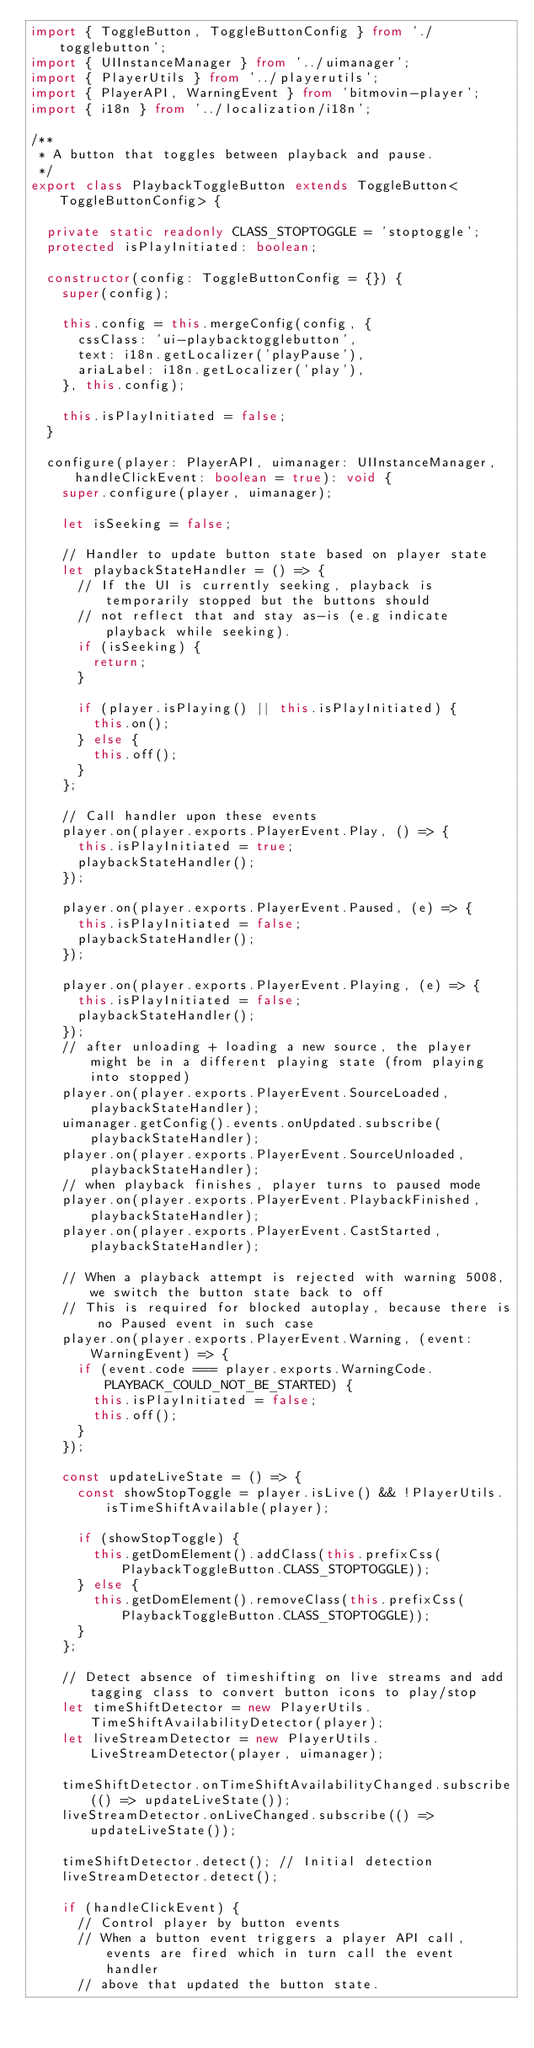<code> <loc_0><loc_0><loc_500><loc_500><_TypeScript_>import { ToggleButton, ToggleButtonConfig } from './togglebutton';
import { UIInstanceManager } from '../uimanager';
import { PlayerUtils } from '../playerutils';
import { PlayerAPI, WarningEvent } from 'bitmovin-player';
import { i18n } from '../localization/i18n';

/**
 * A button that toggles between playback and pause.
 */
export class PlaybackToggleButton extends ToggleButton<ToggleButtonConfig> {

  private static readonly CLASS_STOPTOGGLE = 'stoptoggle';
  protected isPlayInitiated: boolean;

  constructor(config: ToggleButtonConfig = {}) {
    super(config);

    this.config = this.mergeConfig(config, {
      cssClass: 'ui-playbacktogglebutton',
      text: i18n.getLocalizer('playPause'),
      ariaLabel: i18n.getLocalizer('play'),
    }, this.config);

    this.isPlayInitiated = false;
  }

  configure(player: PlayerAPI, uimanager: UIInstanceManager, handleClickEvent: boolean = true): void {
    super.configure(player, uimanager);

    let isSeeking = false;

    // Handler to update button state based on player state
    let playbackStateHandler = () => {
      // If the UI is currently seeking, playback is temporarily stopped but the buttons should
      // not reflect that and stay as-is (e.g indicate playback while seeking).
      if (isSeeking) {
        return;
      }

      if (player.isPlaying() || this.isPlayInitiated) {
        this.on();
      } else {
        this.off();
      }
    };

    // Call handler upon these events
    player.on(player.exports.PlayerEvent.Play, () => {
      this.isPlayInitiated = true;
      playbackStateHandler();
    });

    player.on(player.exports.PlayerEvent.Paused, (e) => {
      this.isPlayInitiated = false;
      playbackStateHandler();
    });

    player.on(player.exports.PlayerEvent.Playing, (e) => {
      this.isPlayInitiated = false;
      playbackStateHandler();
    });
    // after unloading + loading a new source, the player might be in a different playing state (from playing into stopped)
    player.on(player.exports.PlayerEvent.SourceLoaded, playbackStateHandler);
    uimanager.getConfig().events.onUpdated.subscribe(playbackStateHandler);
    player.on(player.exports.PlayerEvent.SourceUnloaded, playbackStateHandler);
    // when playback finishes, player turns to paused mode
    player.on(player.exports.PlayerEvent.PlaybackFinished, playbackStateHandler);
    player.on(player.exports.PlayerEvent.CastStarted, playbackStateHandler);

    // When a playback attempt is rejected with warning 5008, we switch the button state back to off
    // This is required for blocked autoplay, because there is no Paused event in such case
    player.on(player.exports.PlayerEvent.Warning, (event: WarningEvent) => {
      if (event.code === player.exports.WarningCode.PLAYBACK_COULD_NOT_BE_STARTED) {
        this.isPlayInitiated = false;
        this.off();
      }
    });

    const updateLiveState = () => {
      const showStopToggle = player.isLive() && !PlayerUtils.isTimeShiftAvailable(player);

      if (showStopToggle) {
        this.getDomElement().addClass(this.prefixCss(PlaybackToggleButton.CLASS_STOPTOGGLE));
      } else {
        this.getDomElement().removeClass(this.prefixCss(PlaybackToggleButton.CLASS_STOPTOGGLE));
      }
    };

    // Detect absence of timeshifting on live streams and add tagging class to convert button icons to play/stop
    let timeShiftDetector = new PlayerUtils.TimeShiftAvailabilityDetector(player);
    let liveStreamDetector = new PlayerUtils.LiveStreamDetector(player, uimanager);

    timeShiftDetector.onTimeShiftAvailabilityChanged.subscribe(() => updateLiveState());
    liveStreamDetector.onLiveChanged.subscribe(() => updateLiveState());

    timeShiftDetector.detect(); // Initial detection
    liveStreamDetector.detect();

    if (handleClickEvent) {
      // Control player by button events
      // When a button event triggers a player API call, events are fired which in turn call the event handler
      // above that updated the button state.</code> 